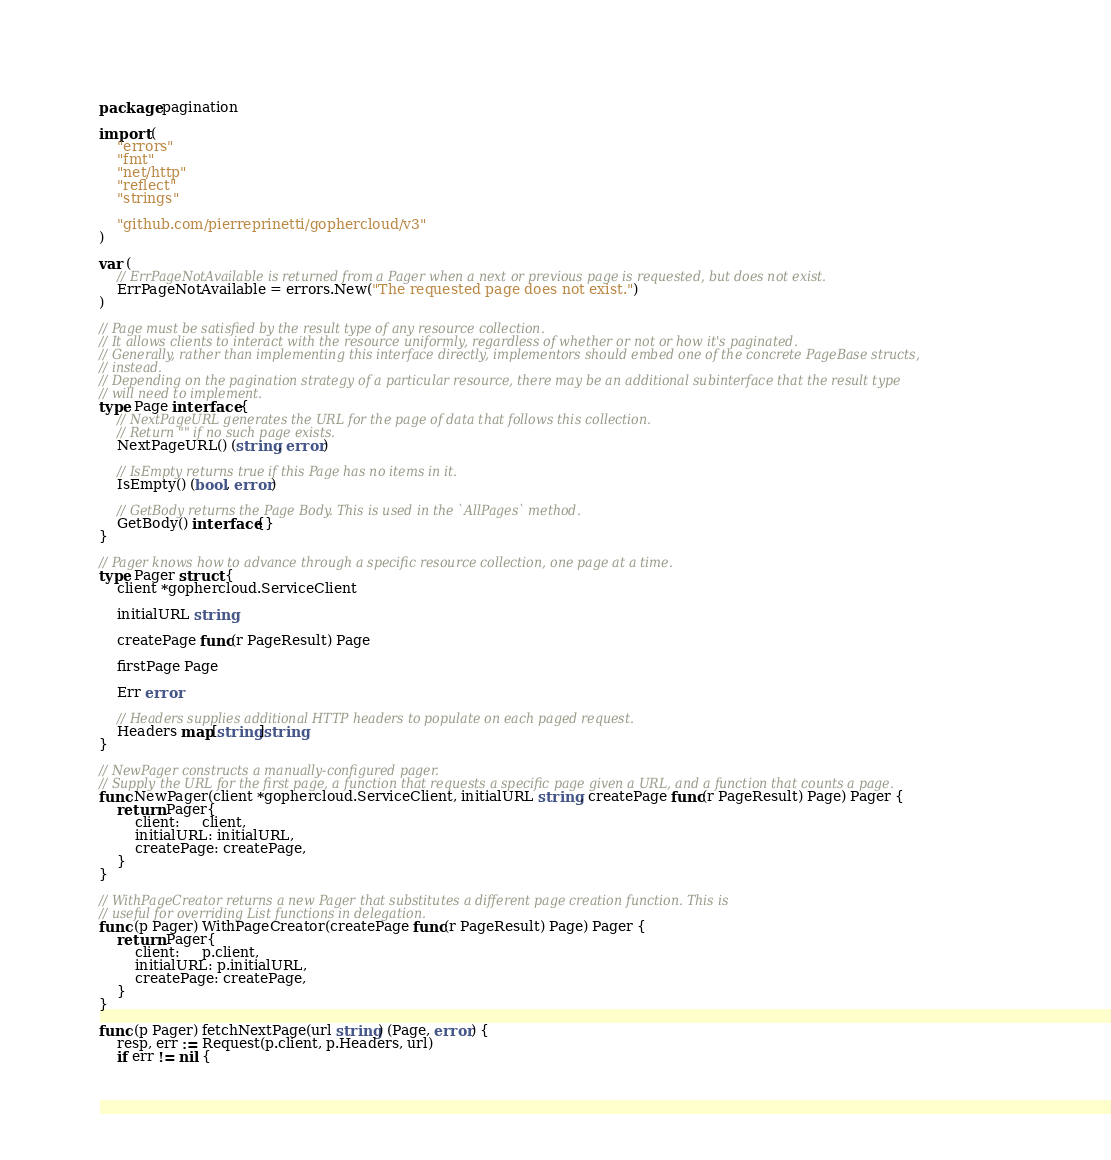<code> <loc_0><loc_0><loc_500><loc_500><_Go_>package pagination

import (
	"errors"
	"fmt"
	"net/http"
	"reflect"
	"strings"

	"github.com/pierreprinetti/gophercloud/v3"
)

var (
	// ErrPageNotAvailable is returned from a Pager when a next or previous page is requested, but does not exist.
	ErrPageNotAvailable = errors.New("The requested page does not exist.")
)

// Page must be satisfied by the result type of any resource collection.
// It allows clients to interact with the resource uniformly, regardless of whether or not or how it's paginated.
// Generally, rather than implementing this interface directly, implementors should embed one of the concrete PageBase structs,
// instead.
// Depending on the pagination strategy of a particular resource, there may be an additional subinterface that the result type
// will need to implement.
type Page interface {
	// NextPageURL generates the URL for the page of data that follows this collection.
	// Return "" if no such page exists.
	NextPageURL() (string, error)

	// IsEmpty returns true if this Page has no items in it.
	IsEmpty() (bool, error)

	// GetBody returns the Page Body. This is used in the `AllPages` method.
	GetBody() interface{}
}

// Pager knows how to advance through a specific resource collection, one page at a time.
type Pager struct {
	client *gophercloud.ServiceClient

	initialURL string

	createPage func(r PageResult) Page

	firstPage Page

	Err error

	// Headers supplies additional HTTP headers to populate on each paged request.
	Headers map[string]string
}

// NewPager constructs a manually-configured pager.
// Supply the URL for the first page, a function that requests a specific page given a URL, and a function that counts a page.
func NewPager(client *gophercloud.ServiceClient, initialURL string, createPage func(r PageResult) Page) Pager {
	return Pager{
		client:     client,
		initialURL: initialURL,
		createPage: createPage,
	}
}

// WithPageCreator returns a new Pager that substitutes a different page creation function. This is
// useful for overriding List functions in delegation.
func (p Pager) WithPageCreator(createPage func(r PageResult) Page) Pager {
	return Pager{
		client:     p.client,
		initialURL: p.initialURL,
		createPage: createPage,
	}
}

func (p Pager) fetchNextPage(url string) (Page, error) {
	resp, err := Request(p.client, p.Headers, url)
	if err != nil {</code> 